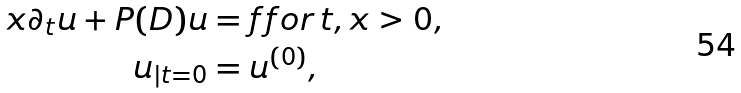<formula> <loc_0><loc_0><loc_500><loc_500>x \partial _ { t } u + P ( D ) u & = f f o r \, t , x > 0 , \\ u _ { | t = 0 } & = u ^ { ( 0 ) } ,</formula> 